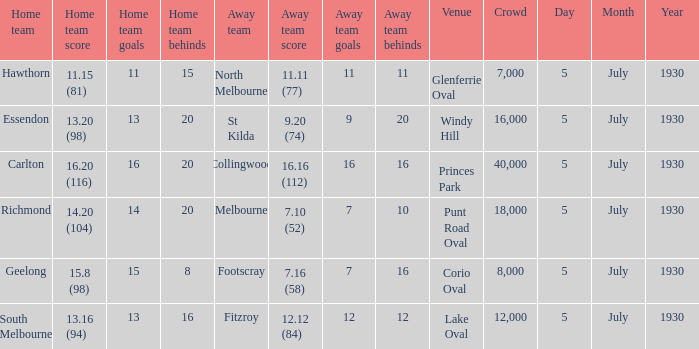Which team is the away side at corio oval? Footscray. 